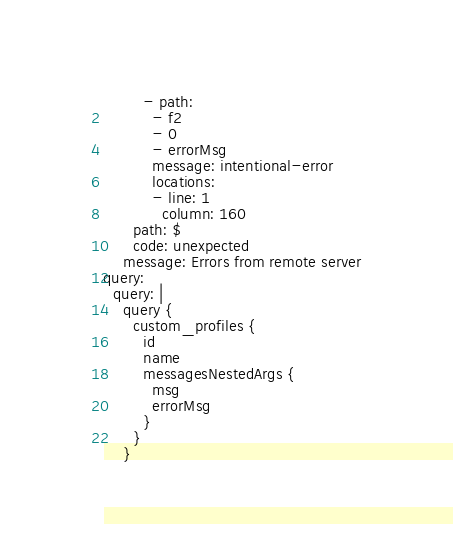<code> <loc_0><loc_0><loc_500><loc_500><_YAML_>        - path:
          - f2
          - 0
          - errorMsg
          message: intentional-error
          locations:
          - line: 1
            column: 160
      path: $
      code: unexpected
    message: Errors from remote server
query:
  query: |
    query {
      custom_profiles {
        id
        name
        messagesNestedArgs {
          msg
          errorMsg
        }
      }
    }
</code> 